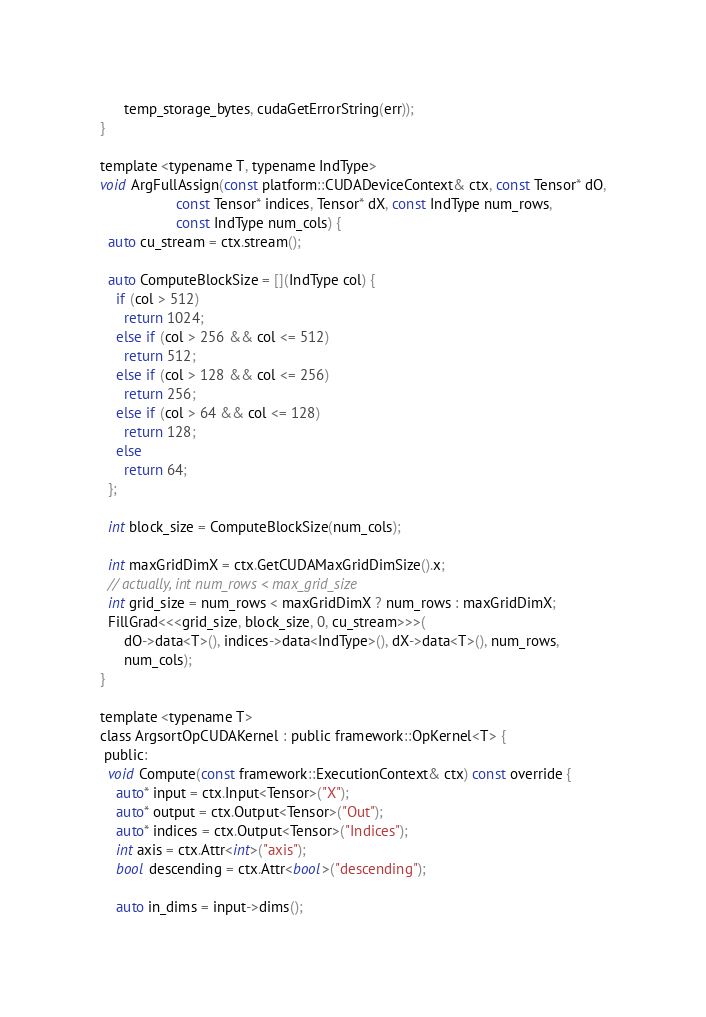Convert code to text. <code><loc_0><loc_0><loc_500><loc_500><_Cuda_>      temp_storage_bytes, cudaGetErrorString(err));
}

template <typename T, typename IndType>
void ArgFullAssign(const platform::CUDADeviceContext& ctx, const Tensor* dO,
                   const Tensor* indices, Tensor* dX, const IndType num_rows,
                   const IndType num_cols) {
  auto cu_stream = ctx.stream();

  auto ComputeBlockSize = [](IndType col) {
    if (col > 512)
      return 1024;
    else if (col > 256 && col <= 512)
      return 512;
    else if (col > 128 && col <= 256)
      return 256;
    else if (col > 64 && col <= 128)
      return 128;
    else
      return 64;
  };

  int block_size = ComputeBlockSize(num_cols);

  int maxGridDimX = ctx.GetCUDAMaxGridDimSize().x;
  // actually, int num_rows < max_grid_size
  int grid_size = num_rows < maxGridDimX ? num_rows : maxGridDimX;
  FillGrad<<<grid_size, block_size, 0, cu_stream>>>(
      dO->data<T>(), indices->data<IndType>(), dX->data<T>(), num_rows,
      num_cols);
}

template <typename T>
class ArgsortOpCUDAKernel : public framework::OpKernel<T> {
 public:
  void Compute(const framework::ExecutionContext& ctx) const override {
    auto* input = ctx.Input<Tensor>("X");
    auto* output = ctx.Output<Tensor>("Out");
    auto* indices = ctx.Output<Tensor>("Indices");
    int axis = ctx.Attr<int>("axis");
    bool descending = ctx.Attr<bool>("descending");

    auto in_dims = input->dims();</code> 